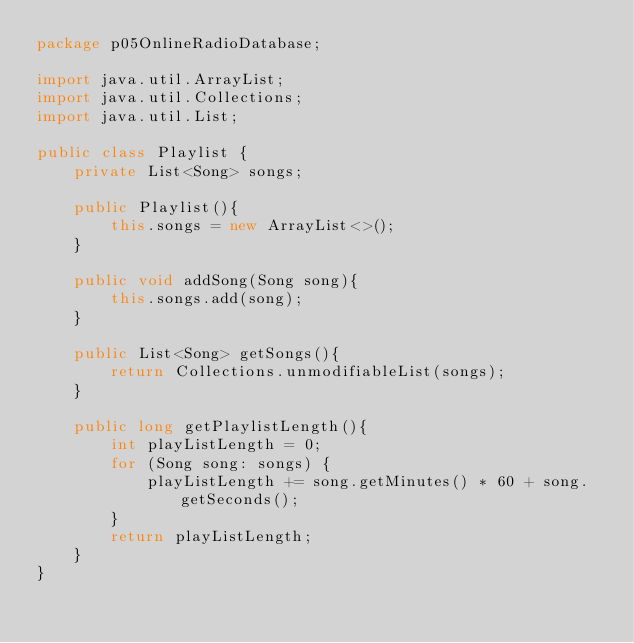<code> <loc_0><loc_0><loc_500><loc_500><_Java_>package p05OnlineRadioDatabase;

import java.util.ArrayList;
import java.util.Collections;
import java.util.List;

public class Playlist {
    private List<Song> songs;

    public Playlist(){
        this.songs = new ArrayList<>();
    }

    public void addSong(Song song){
        this.songs.add(song);
    }

    public List<Song> getSongs(){
        return Collections.unmodifiableList(songs);
    }

    public long getPlaylistLength(){
        int playListLength = 0;
        for (Song song: songs) {
            playListLength += song.getMinutes() * 60 + song.getSeconds();
        }
        return playListLength;
    }
}
</code> 